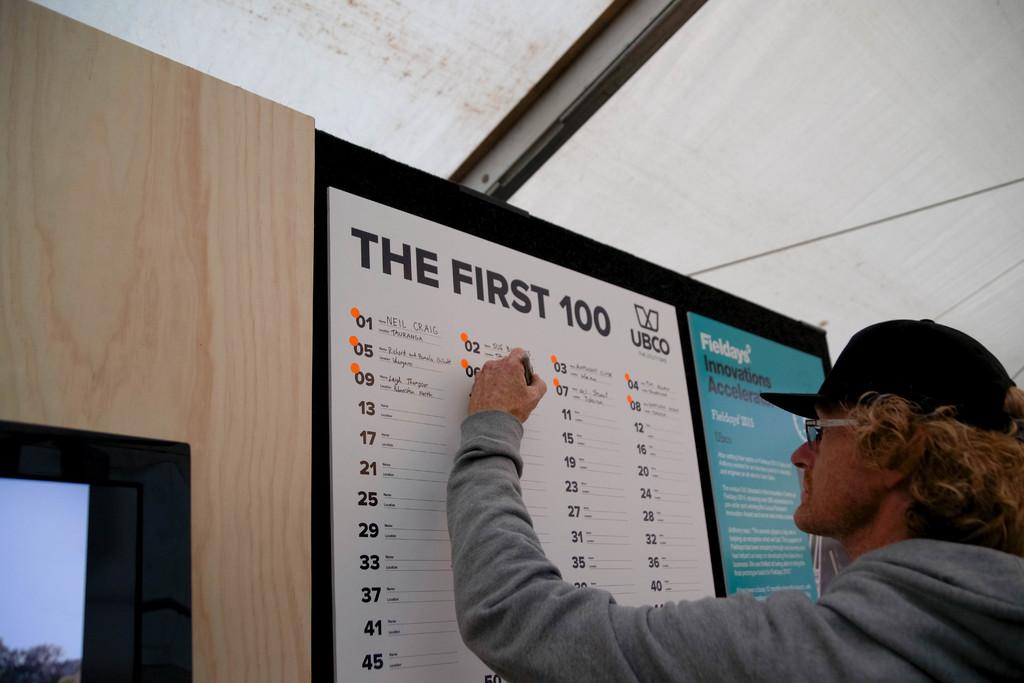What is the first name on the list?
Your response must be concise. Neil craig. How many names fit on this list?
Ensure brevity in your answer.  100. 